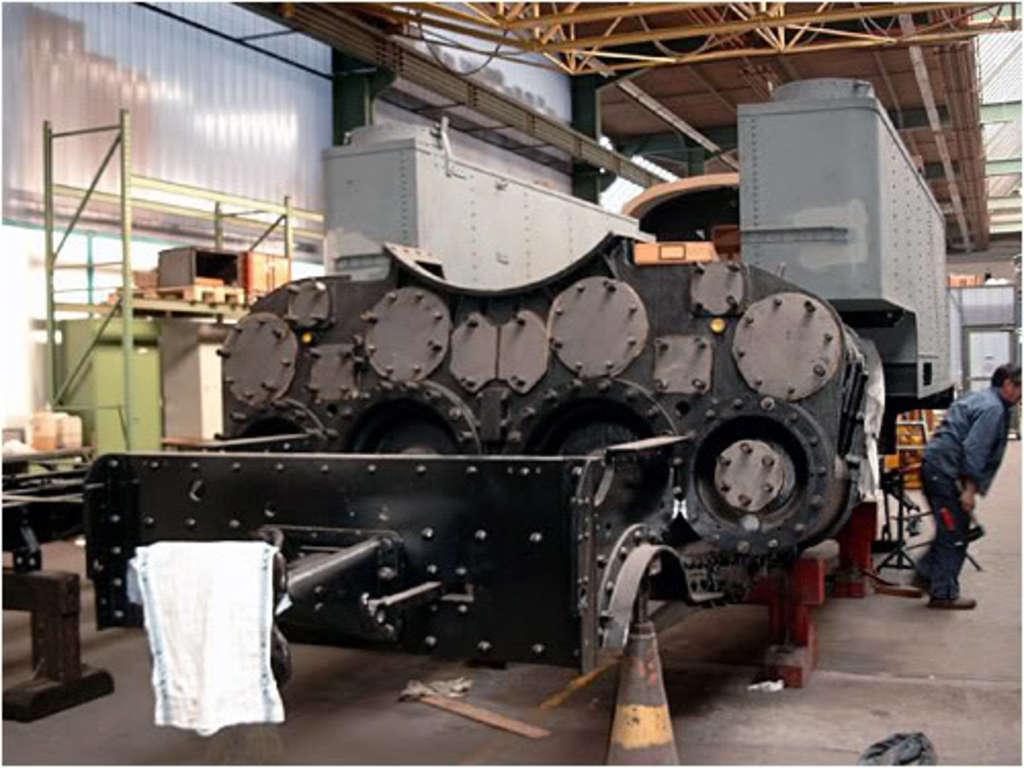How would you summarize this image in a sentence or two? In this image I can see an iron part of a big vehicle. At the top there is a shed, on the right side there is a man. 